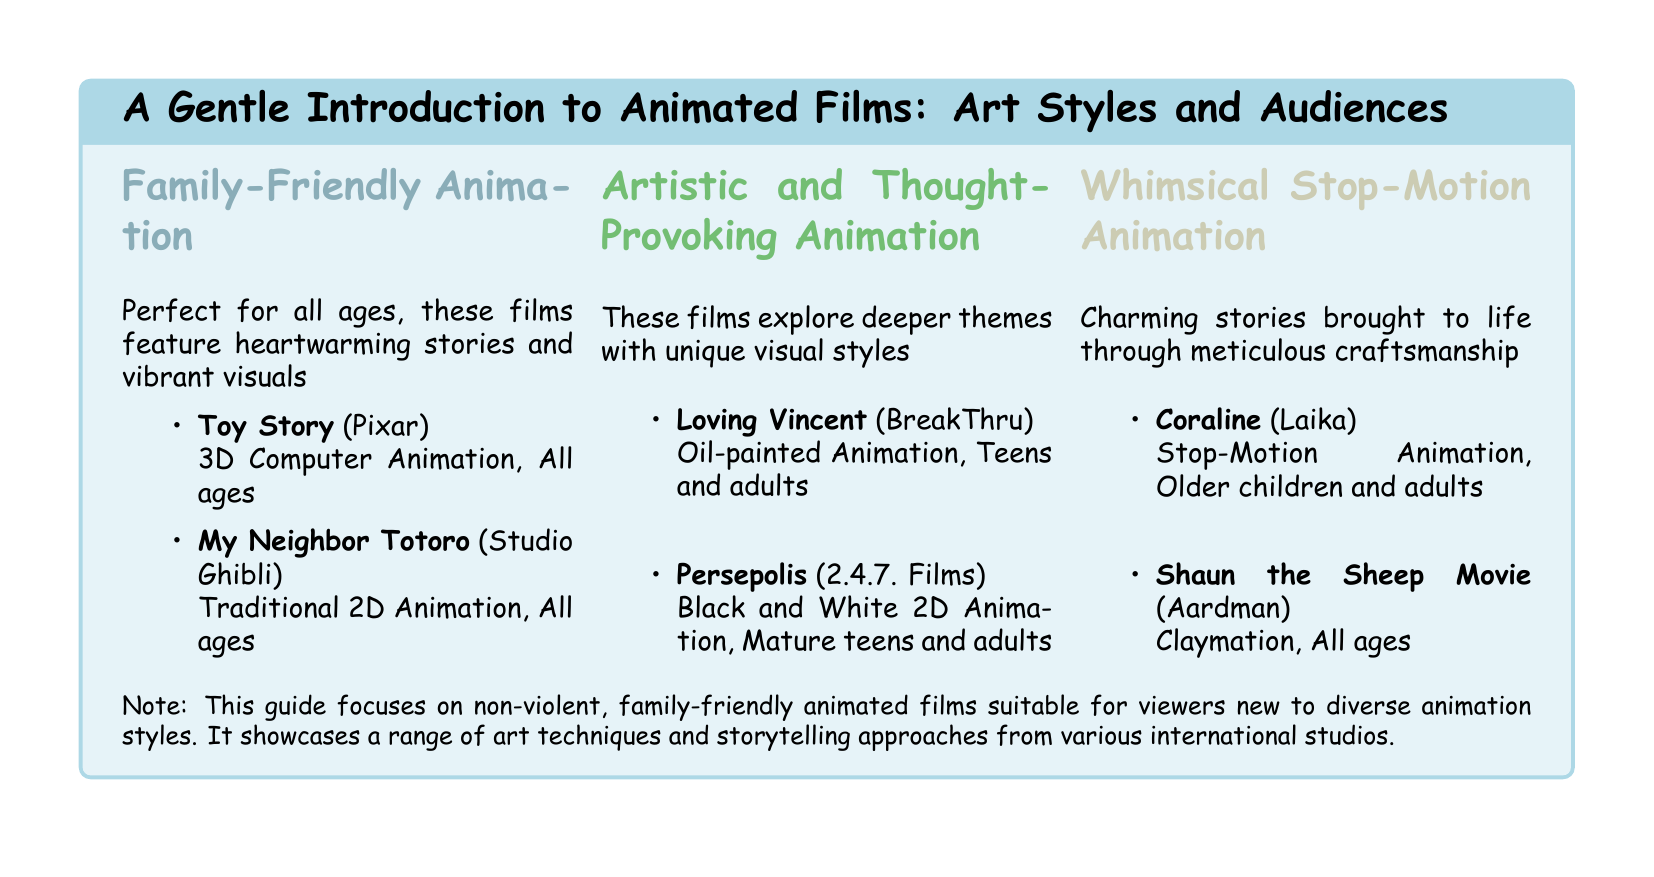What is the art style of "Toy Story"? "Toy Story" is categorized as 3D Computer Animation.
Answer: 3D Computer Animation Who produced "My Neighbor Totoro"? "My Neighbor Totoro" is produced by Studio Ghibli.
Answer: Studio Ghibli Which target audience is "Loving Vincent" suited for? "Loving Vincent" is suitable for Teens and adults.
Answer: Teens and adults What animation technique is used in "Coraline"? "Coraline" uses Stop-Motion Animation.
Answer: Stop-Motion Animation How many films are listed under Family-Friendly Animation? There are two films listed under Family-Friendly Animation.
Answer: 2 Which studio created "Shaun the Sheep Movie"? "Shaun the Sheep Movie" was created by Aardman.
Answer: Aardman What is the primary theme of Artistic and Thought-Provoking Animation? The primary theme explores deeper themes with unique visual styles.
Answer: Deeper themes How does the document categorize the recommended films? The document categorizes films by art style and target audience.
Answer: Art style and target audience What type of guide is this document referring to? This document refers to a guide focusing on non-violent, family-friendly animated films.
Answer: Non-violent, family-friendly animated films 